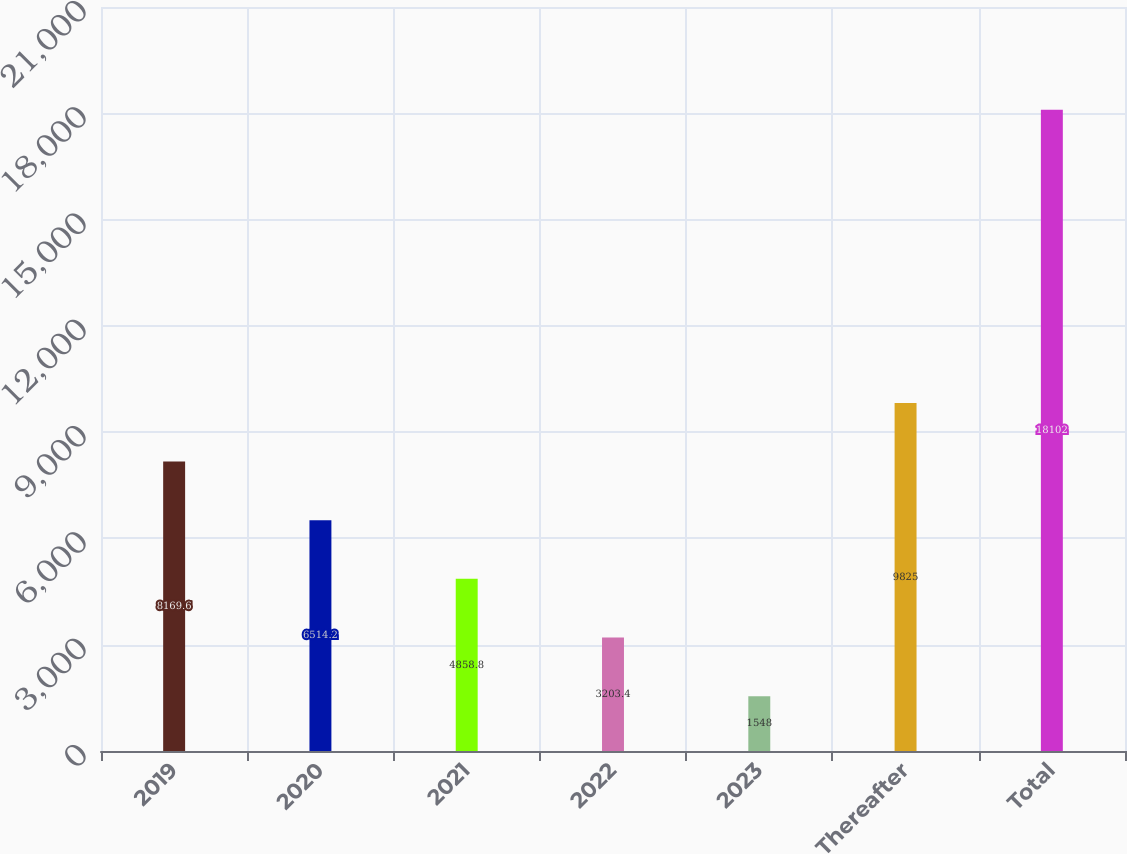<chart> <loc_0><loc_0><loc_500><loc_500><bar_chart><fcel>2019<fcel>2020<fcel>2021<fcel>2022<fcel>2023<fcel>Thereafter<fcel>Total<nl><fcel>8169.6<fcel>6514.2<fcel>4858.8<fcel>3203.4<fcel>1548<fcel>9825<fcel>18102<nl></chart> 